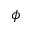Convert formula to latex. <formula><loc_0><loc_0><loc_500><loc_500>\phi</formula> 